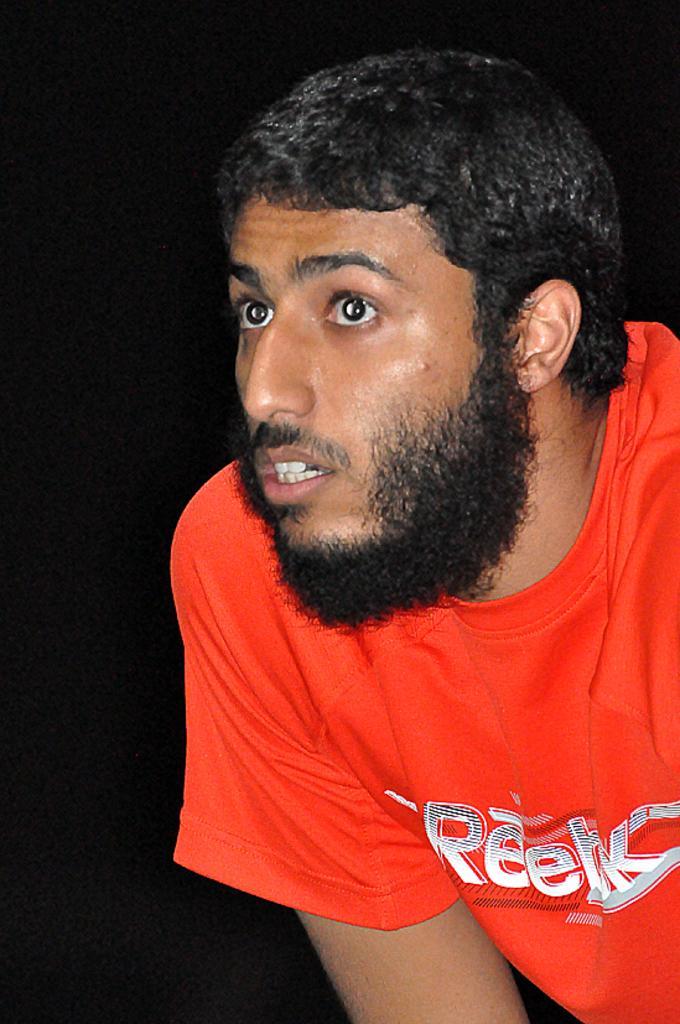Can you describe this image briefly? In this picture I can observe a man in the middle of the picture. He is wearing red color T shirt. The background is completely dark. 